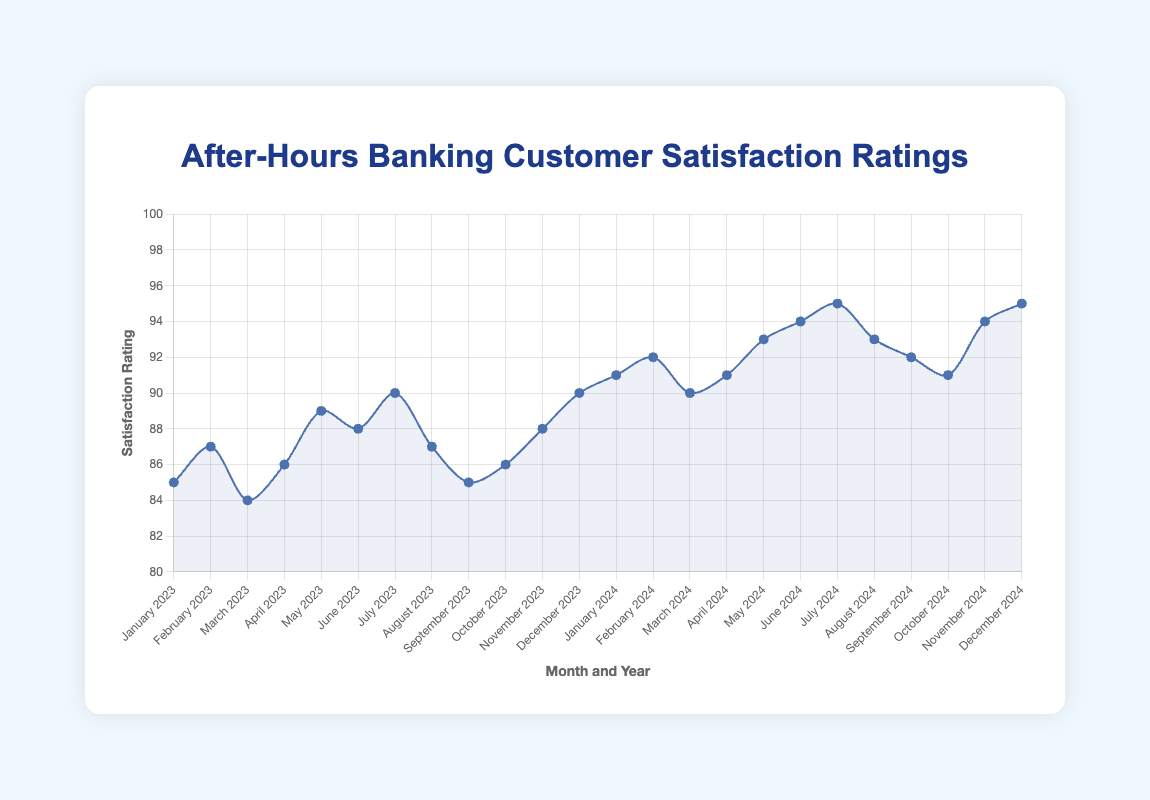What is the customer satisfaction rating for June 2023? Locate June 2023 on the x-axis and find the corresponding point on the line. The y-axis value for this point reads 88.
Answer: 88 Which month in 2024 had the highest customer satisfaction rating? Look along the x-axis for the highest point on the line in the year 2024. This highest point appears in December 2024 with a rating of 95.
Answer: December 2024 How does the customer satisfaction rating in February 2023 compare to February 2024? Locate both February 2023 and February 2024 on the x-axis and compare their y-axis values. February 2023 has a rating of 87, while February 2024 has a rating of 92. 92 is greater than 87.
Answer: February 2024 has a higher rating What is the average customer satisfaction rating for the first quarter of 2023 (January to March)? Add the ratings for January, February, and March 2023: (85 + 87 + 84) = 256. Divide by 3 to get the average: 256 / 3 ≈ 85.33.
Answer: ~85.33 Between which two consecutive months in 2024 did the customer satisfaction rating increase the most? Calculate the difference between consecutive months in 2024. The largest increase is between January (91) and February (92), with an increase of 1.
Answer: January to February During which month in 2024 did the customer satisfaction rating decline from the previous month? Identify any decline by comparing the ratings of consecutive months in 2024. The rating declines between August (93) and September (92) and again between September (92) and October (91).
Answer: August to September and September to October What is the overall trend in customer satisfaction ratings from January 2023 to December 2024? Observe the line from January 2023 to December 2024. The overall trend shows an increase in customer satisfaction ratings, peaking towards the end of 2024.
Answer: Increasing trend What is the difference in customer satisfaction ratings between January 2023 and January 2024? Subtract the January 2023 rating from the January 2024 rating: 91 - 85 = 6.
Answer: 6 Among July 2023 and July 2024, which one has a higher customer satisfaction rating? Compare the y-axis values for both July months. July 2023 has a rating of 90, whereas July 2024 has a rating of 95. 95 is higher than 90.
Answer: July 2024 How many months in 2024 had a satisfaction rating of 94 or higher? Count the months in 2024 where the rating is 94 or higher. June, November, and December 2024 meet this criteria, totaling 3 months.
Answer: 3 